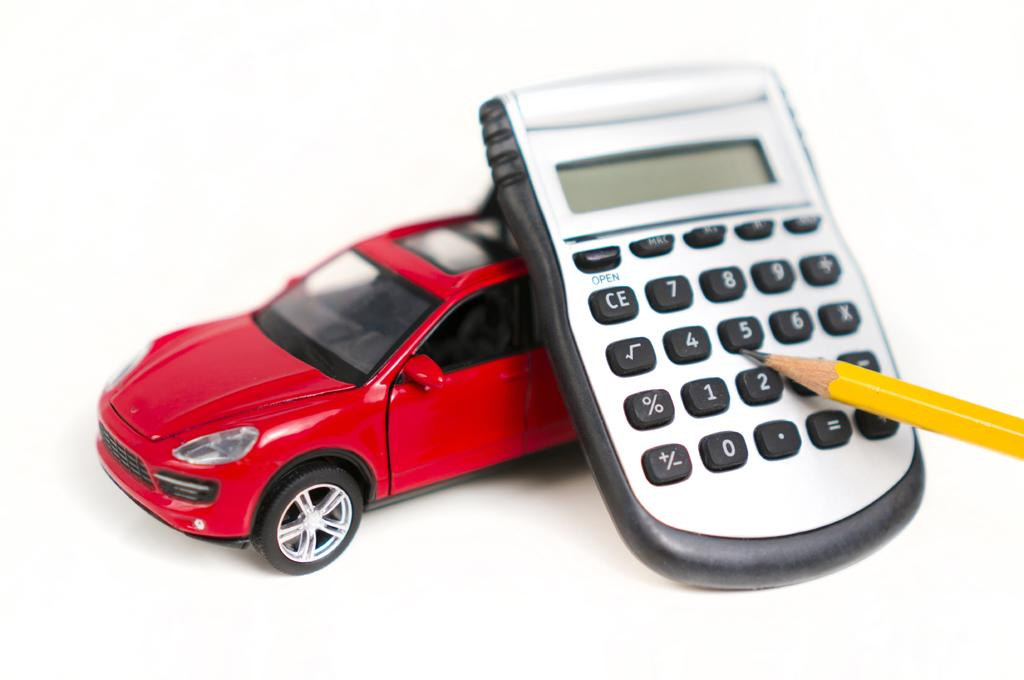What type of toy is in the image? There is a red toy car in the image. What other object can be seen in the image? There is a calculator in the image. What stationery item is present in the image? There is a yellow pencil in the image. What color is the background of the image? The background of the image is white. What type of reaction does the calculator have when the pencil is used on it? There is no reaction depicted in the image, as the calculator and pencil are separate objects. Who is the expert in the image? There is no expert present in the image; it features a red toy car, a calculator, and a yellow pencil. 